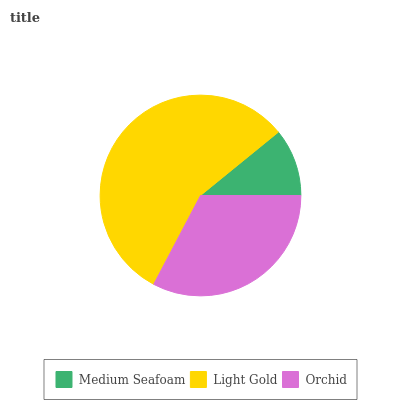Is Medium Seafoam the minimum?
Answer yes or no. Yes. Is Light Gold the maximum?
Answer yes or no. Yes. Is Orchid the minimum?
Answer yes or no. No. Is Orchid the maximum?
Answer yes or no. No. Is Light Gold greater than Orchid?
Answer yes or no. Yes. Is Orchid less than Light Gold?
Answer yes or no. Yes. Is Orchid greater than Light Gold?
Answer yes or no. No. Is Light Gold less than Orchid?
Answer yes or no. No. Is Orchid the high median?
Answer yes or no. Yes. Is Orchid the low median?
Answer yes or no. Yes. Is Light Gold the high median?
Answer yes or no. No. Is Light Gold the low median?
Answer yes or no. No. 